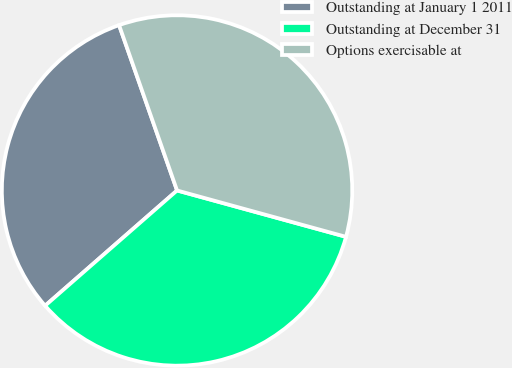<chart> <loc_0><loc_0><loc_500><loc_500><pie_chart><fcel>Outstanding at January 1 2011<fcel>Outstanding at December 31<fcel>Options exercisable at<nl><fcel>31.06%<fcel>34.31%<fcel>34.63%<nl></chart> 